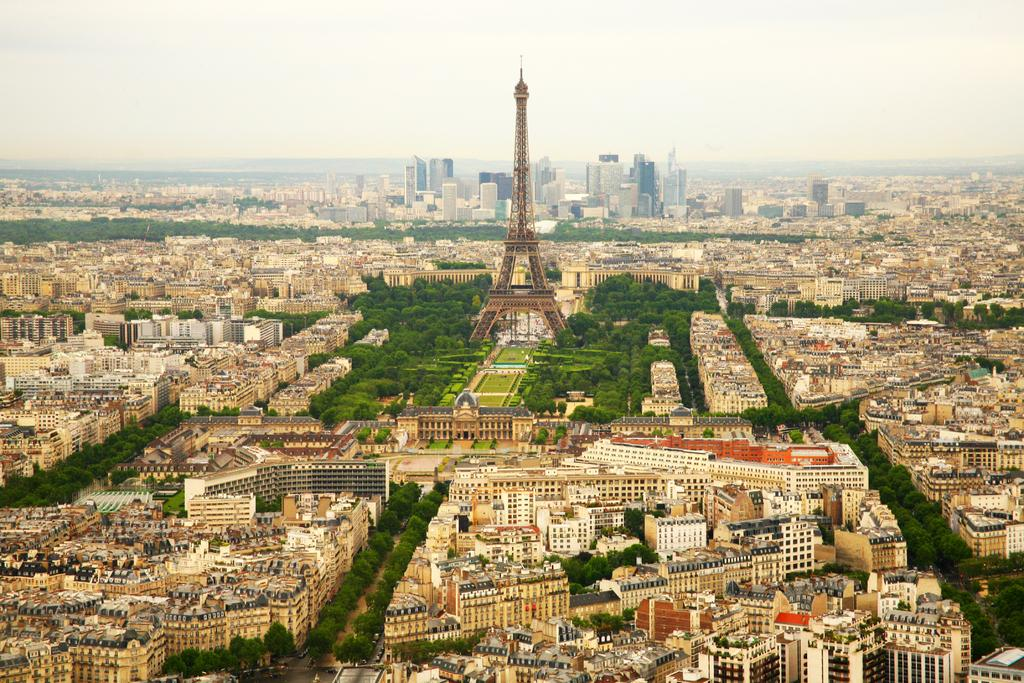What type of view is shown in the image? The image depicts an aerial view of a city. What can be seen on the ground in the image? There are roads, trees, and buildings visible in the image. What is the most prominent feature in the image? The Eiffel Tower is visible in the image. What type of buildings can be seen in the image? Skyscrapers are present in the image. What is visible above the city in the image? The sky is visible in the image. Where is the bed located in the image? There is no bed present in the image; it depicts an aerial view of a city. What type of development is taking place in the image? The image does not show any specific development; it is a general view of a city with roads, trees, buildings, and the Eiffel Tower. 